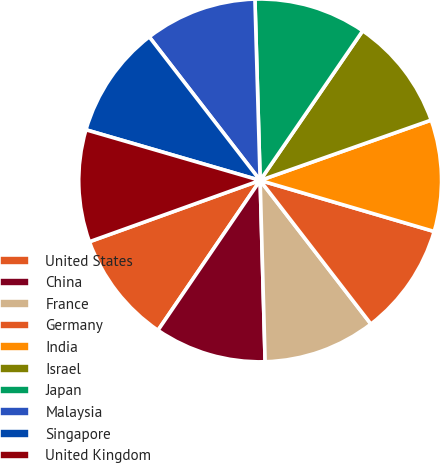Convert chart. <chart><loc_0><loc_0><loc_500><loc_500><pie_chart><fcel>United States<fcel>China<fcel>France<fcel>Germany<fcel>India<fcel>Israel<fcel>Japan<fcel>Malaysia<fcel>Singapore<fcel>United Kingdom<nl><fcel>9.99%<fcel>9.96%<fcel>10.02%<fcel>10.0%<fcel>9.94%<fcel>10.04%<fcel>10.02%<fcel>10.01%<fcel>10.03%<fcel>9.99%<nl></chart> 